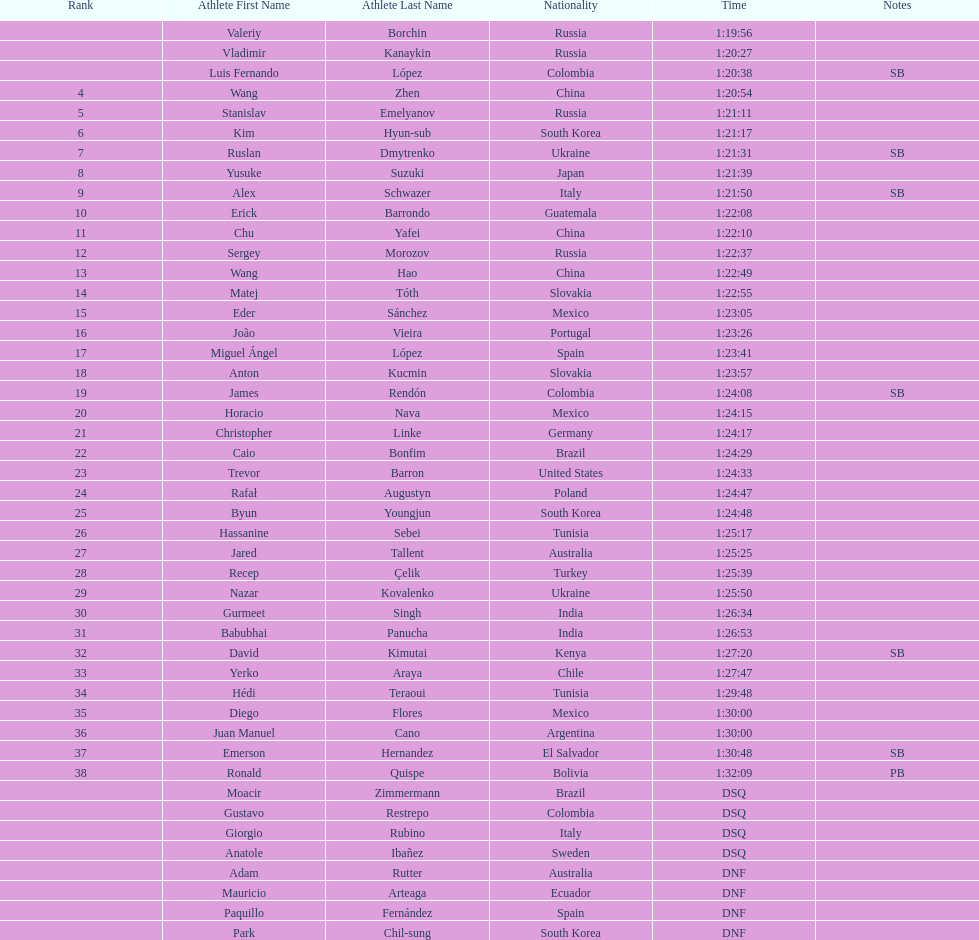What is the total count of athletes included in the rankings chart, including those classified as dsq & dnf? 46. 